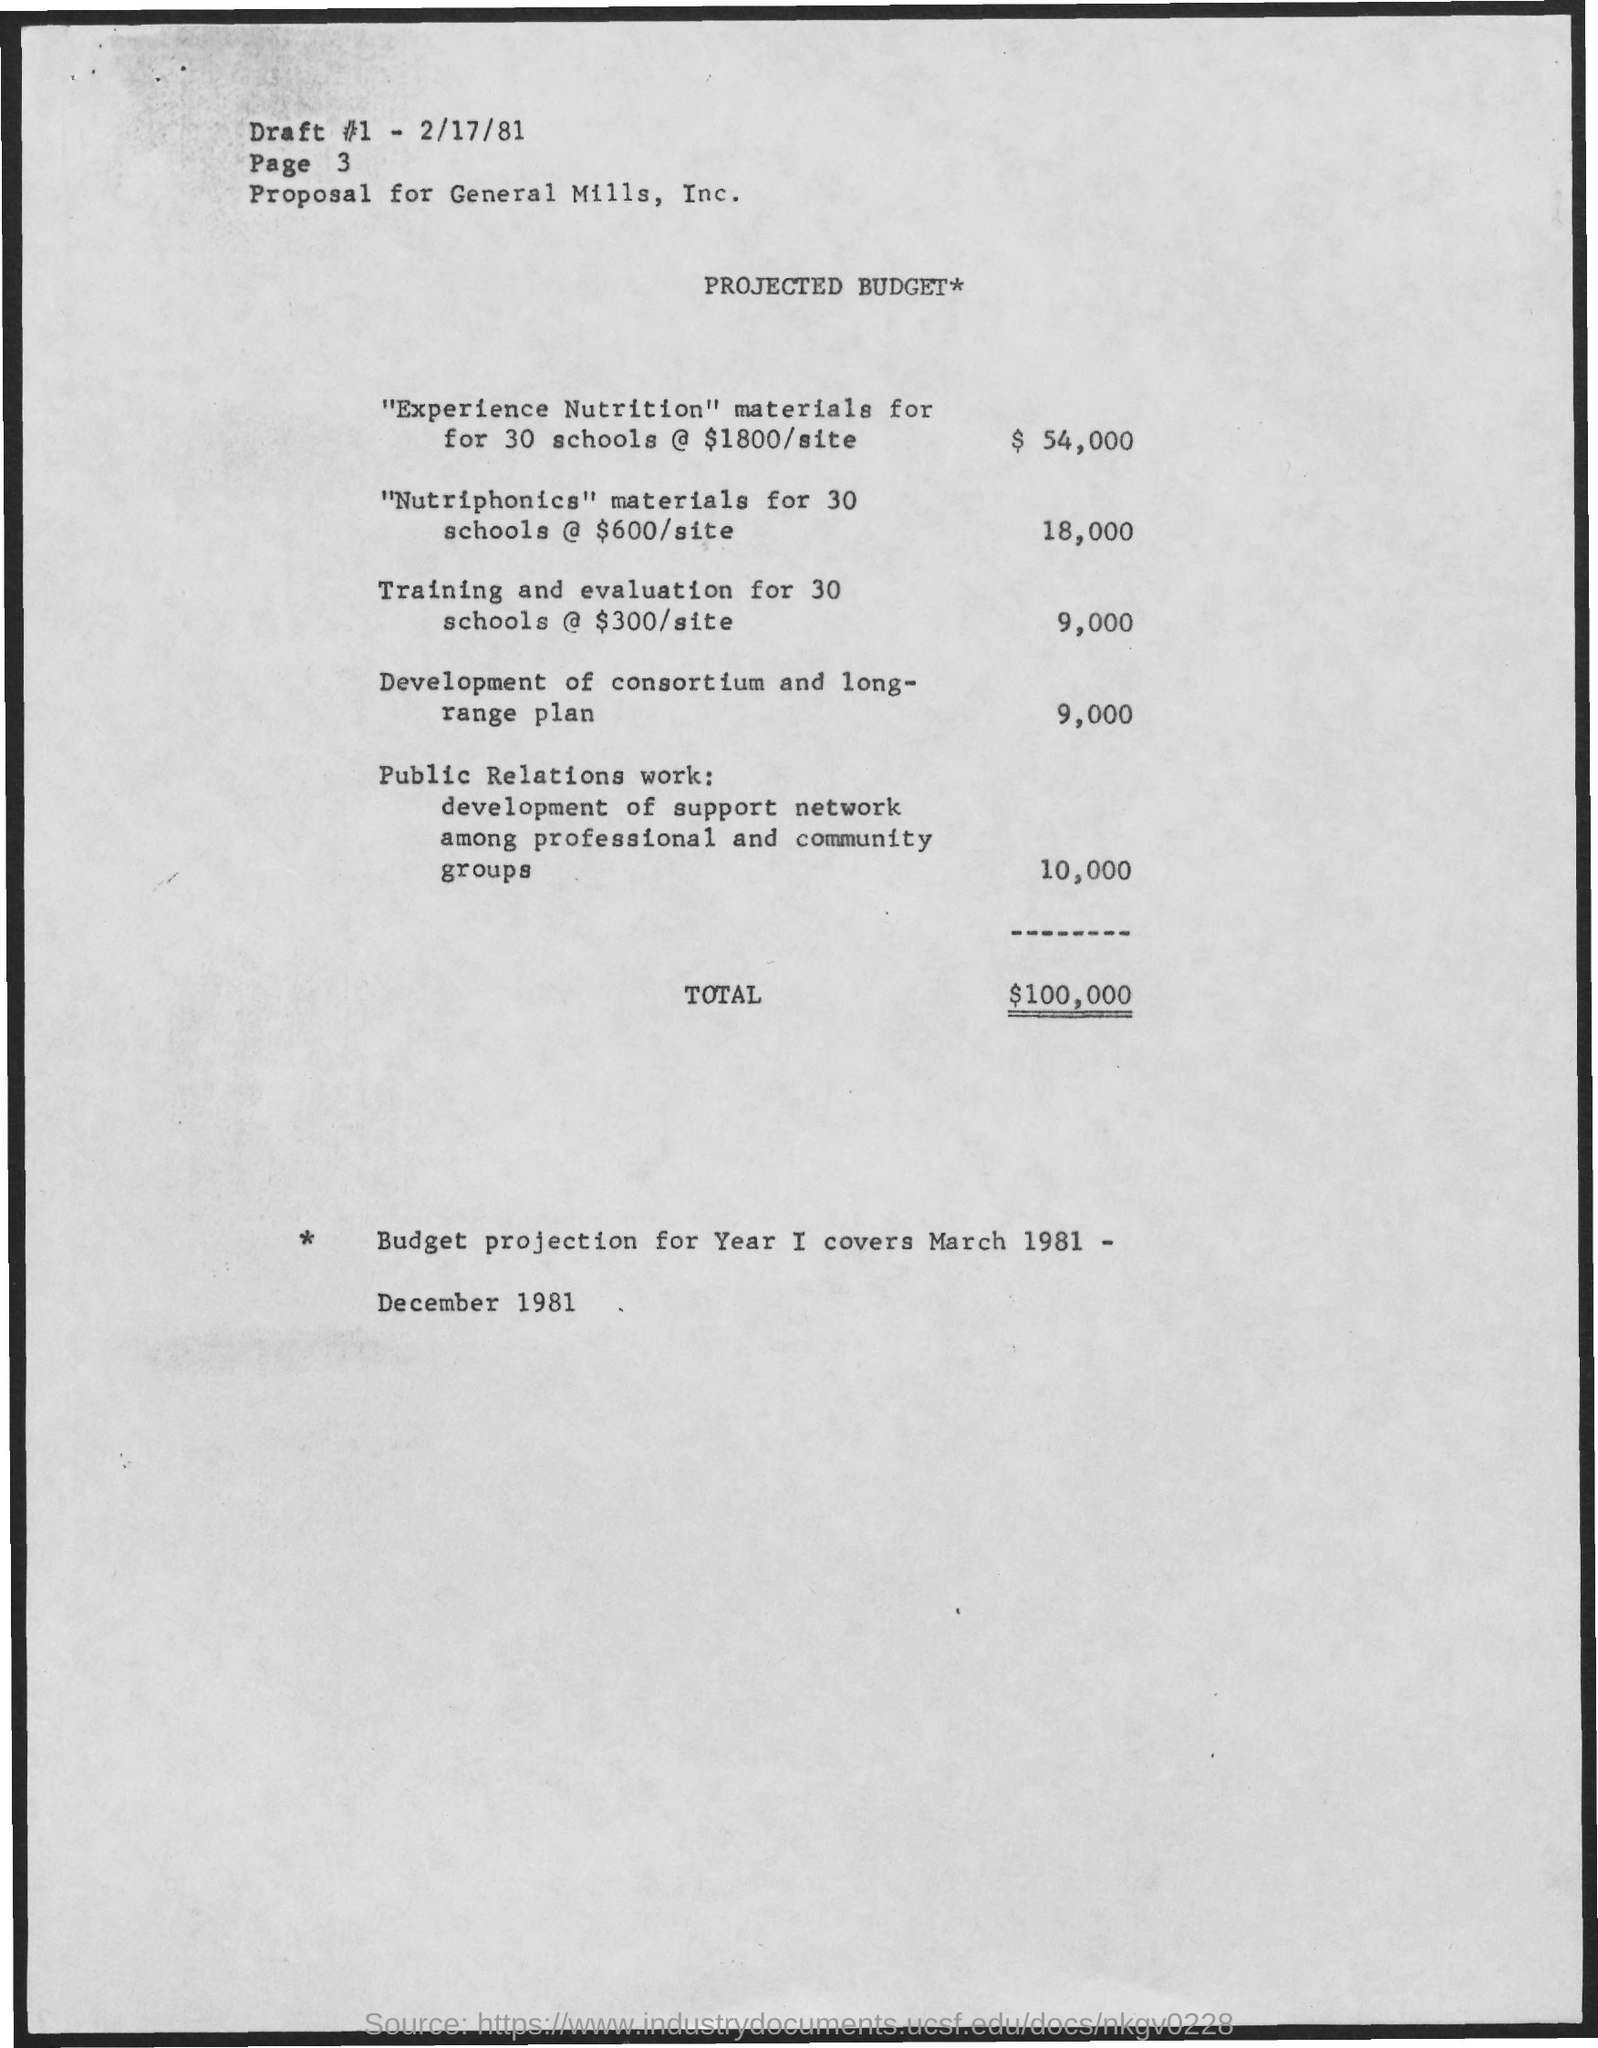What is the Draft #1?
Offer a very short reply. 2/17/81. What is the Title of the document?
Keep it short and to the point. PROJECTED BUDGET. What is the "experience nutrition" materials for 30 schools @ $1800/site?
Give a very brief answer. $ 54,000. What is the "nutriphonics" materials for 30 schools @ $600/site?
Provide a short and direct response. 18,000. What is the Training and evaluation for 30 schools @ $300/site?
Your answer should be very brief. $9,000. What is the Page?
Your answer should be compact. 3. 